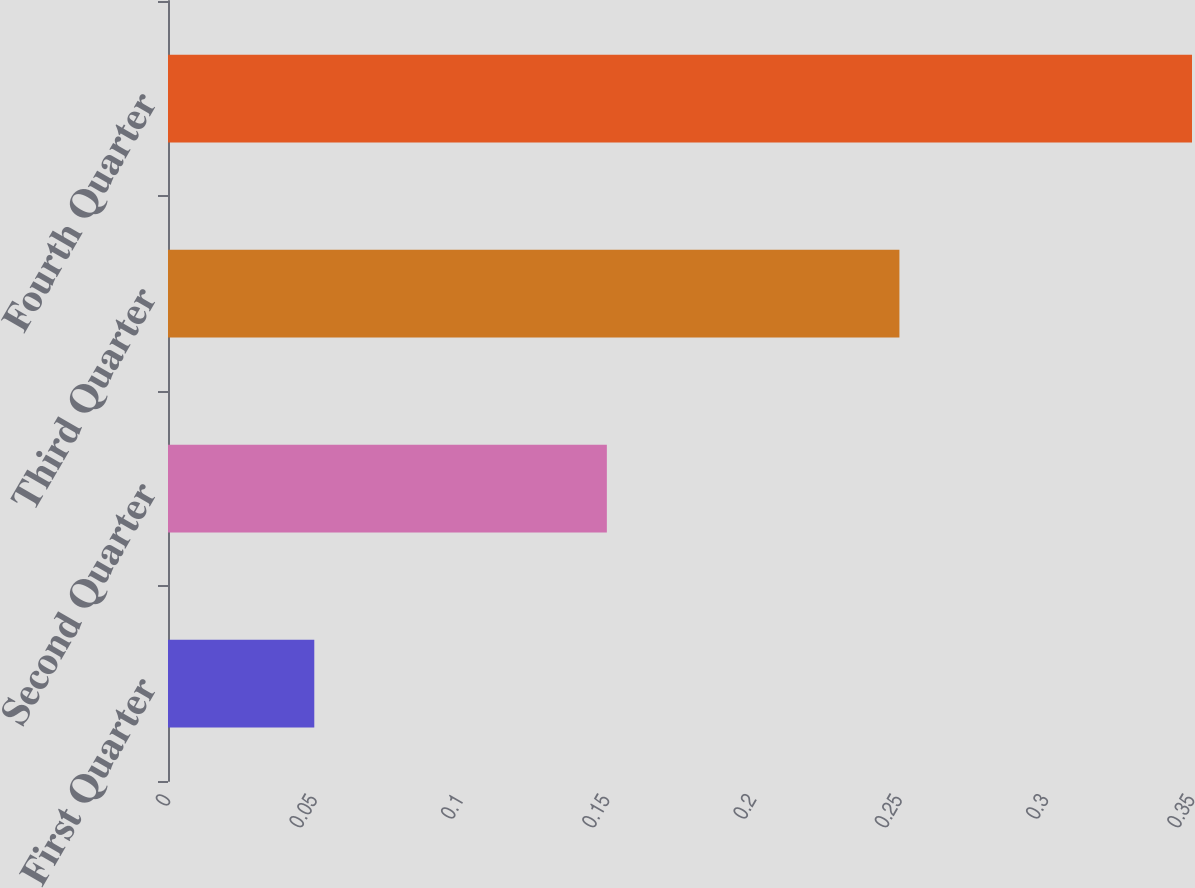<chart> <loc_0><loc_0><loc_500><loc_500><bar_chart><fcel>First Quarter<fcel>Second Quarter<fcel>Third Quarter<fcel>Fourth Quarter<nl><fcel>0.05<fcel>0.15<fcel>0.25<fcel>0.35<nl></chart> 